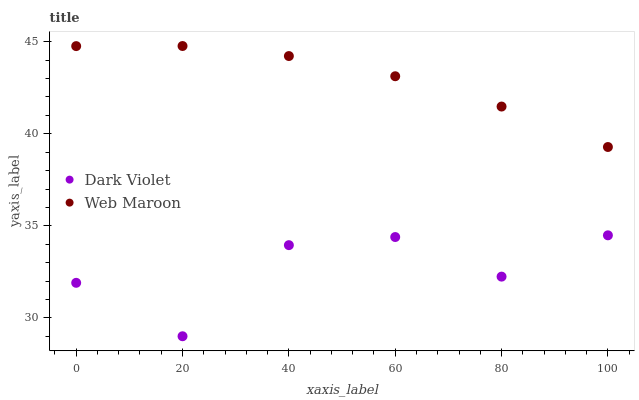Does Dark Violet have the minimum area under the curve?
Answer yes or no. Yes. Does Web Maroon have the maximum area under the curve?
Answer yes or no. Yes. Does Dark Violet have the maximum area under the curve?
Answer yes or no. No. Is Web Maroon the smoothest?
Answer yes or no. Yes. Is Dark Violet the roughest?
Answer yes or no. Yes. Is Dark Violet the smoothest?
Answer yes or no. No. Does Dark Violet have the lowest value?
Answer yes or no. Yes. Does Web Maroon have the highest value?
Answer yes or no. Yes. Does Dark Violet have the highest value?
Answer yes or no. No. Is Dark Violet less than Web Maroon?
Answer yes or no. Yes. Is Web Maroon greater than Dark Violet?
Answer yes or no. Yes. Does Dark Violet intersect Web Maroon?
Answer yes or no. No. 